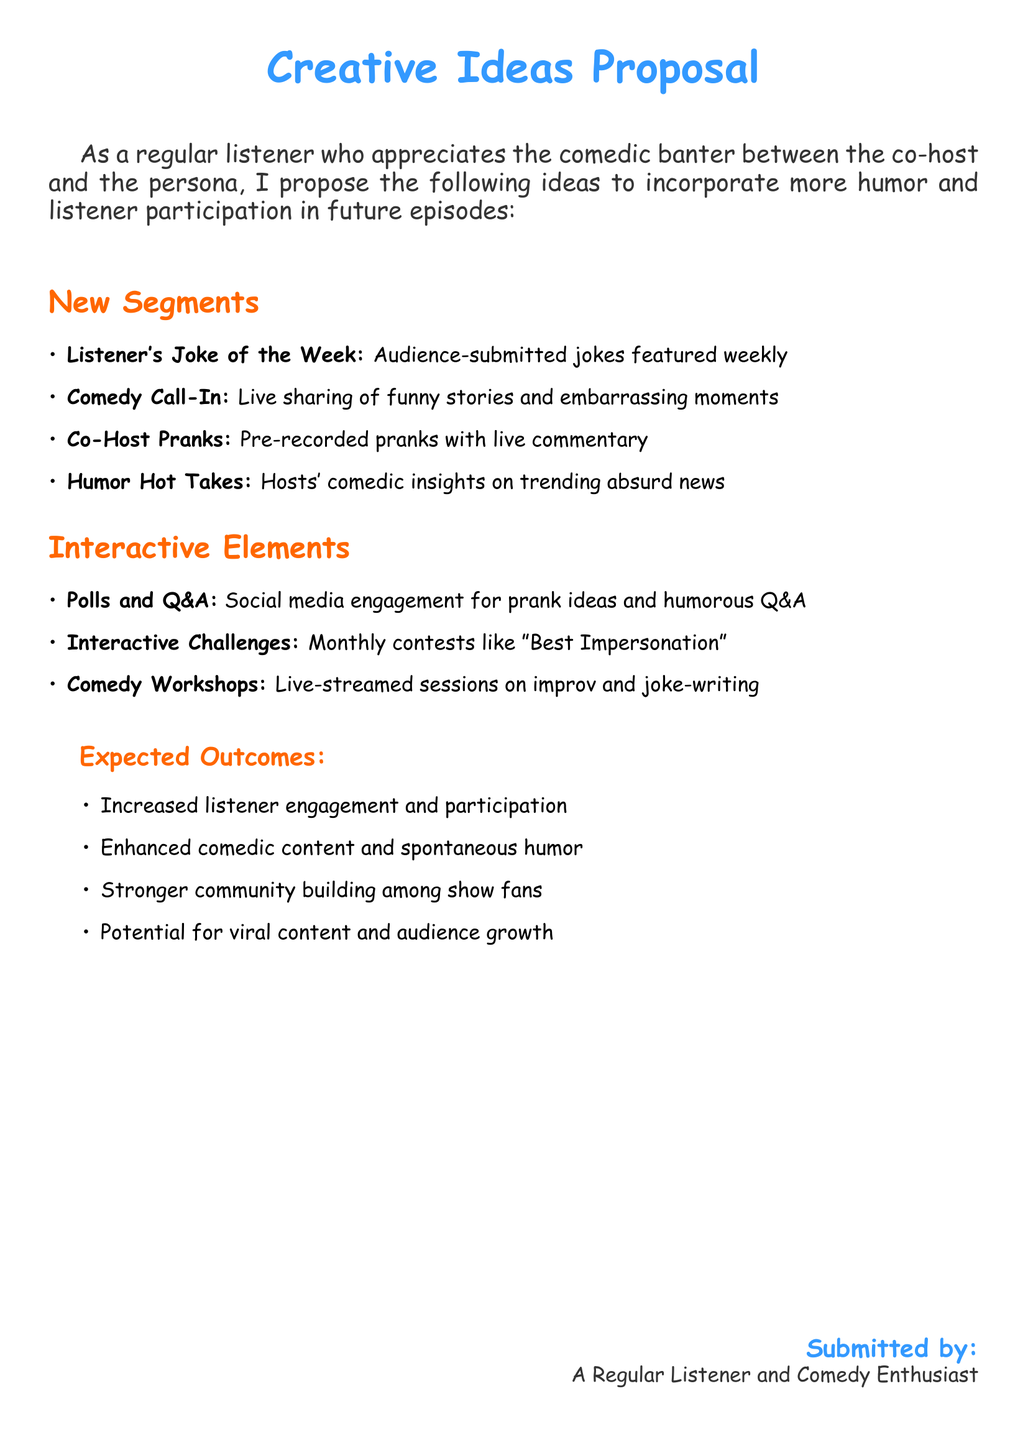what is the title of the proposal? The title of the proposal is prominently displayed at the top of the document.
Answer: Creative Ideas Proposal who submitted the proposal? The submitted by section provides the name of the individual who proposed the ideas.
Answer: A Regular Listener and Comedy Enthusiast how many new segments are proposed? The number of new segments can be counted in the listed items under the New Segments section.
Answer: 4 what is one of the expected outcomes? Expected outcomes are listed in bullet points, and one can be selected from that section.
Answer: Increased listener engagement and participation name one interactive element mentioned in the proposal. Interactive elements are detailed in a list, and any item from that list can be provided as an answer.
Answer: Polls and Q&A which new segment involves live sharing? The proposal includes several segments, and one specifically mentions live sharing.
Answer: Comedy Call-In what type of sessions does the proposal suggest for learning? The document lists various types of engagements, one of which focuses on learning.
Answer: Comedy Workshops what comedic format involves audience submissions? The proposal includes a segment that invites audience involvement through submissions.
Answer: Listener's Joke of the Week 